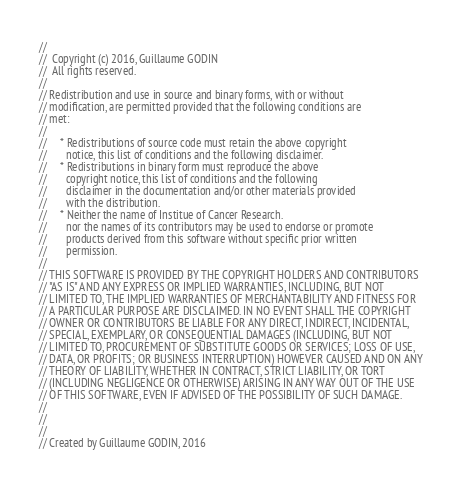Convert code to text. <code><loc_0><loc_0><loc_500><loc_500><_C_>//
//  Copyright (c) 2016, Guillaume GODIN
//  All rights reserved.
//
// Redistribution and use in source and binary forms, with or without
// modification, are permitted provided that the following conditions are
// met:
//
//     * Redistributions of source code must retain the above copyright
//       notice, this list of conditions and the following disclaimer.
//     * Redistributions in binary form must reproduce the above
//       copyright notice, this list of conditions and the following
//       disclaimer in the documentation and/or other materials provided
//       with the distribution.
//     * Neither the name of Institue of Cancer Research.
//       nor the names of its contributors may be used to endorse or promote
//       products derived from this software without specific prior written
//       permission.
//
// THIS SOFTWARE IS PROVIDED BY THE COPYRIGHT HOLDERS AND CONTRIBUTORS
// "AS IS" AND ANY EXPRESS OR IMPLIED WARRANTIES, INCLUDING, BUT NOT
// LIMITED TO, THE IMPLIED WARRANTIES OF MERCHANTABILITY AND FITNESS FOR
// A PARTICULAR PURPOSE ARE DISCLAIMED. IN NO EVENT SHALL THE COPYRIGHT
// OWNER OR CONTRIBUTORS BE LIABLE FOR ANY DIRECT, INDIRECT, INCIDENTAL,
// SPECIAL, EXEMPLARY, OR CONSEQUENTIAL DAMAGES (INCLUDING, BUT NOT
// LIMITED TO, PROCUREMENT OF SUBSTITUTE GOODS OR SERVICES; LOSS OF USE,
// DATA, OR PROFITS; OR BUSINESS INTERRUPTION) HOWEVER CAUSED AND ON ANY
// THEORY OF LIABILITY, WHETHER IN CONTRACT, STRICT LIABILITY, OR TORT
// (INCLUDING NEGLIGENCE OR OTHERWISE) ARISING IN ANY WAY OUT OF THE USE
// OF THIS SOFTWARE, EVEN IF ADVISED OF THE POSSIBILITY OF SUCH DAMAGE.
//
//
//
// Created by Guillaume GODIN, 2016
</code> 